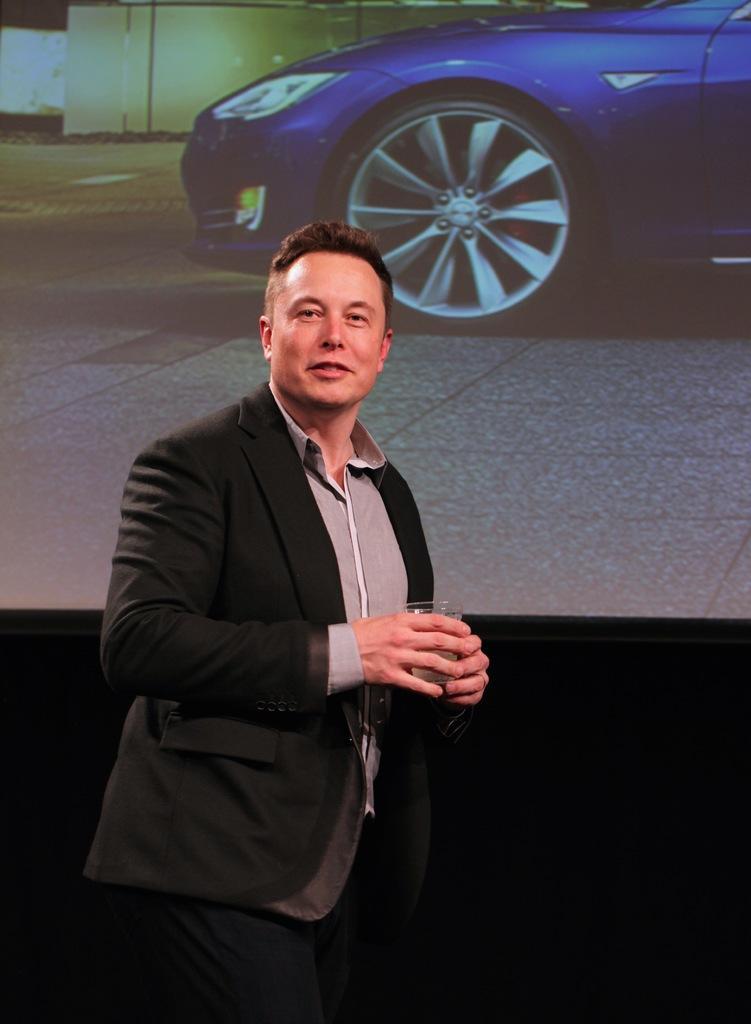Could you give a brief overview of what you see in this image? In this image we can see a person wearing suit holding glass in his hands in which there is some drink and in the background of the image there is a projector screen on which there is some video is displaying which is of about car. 